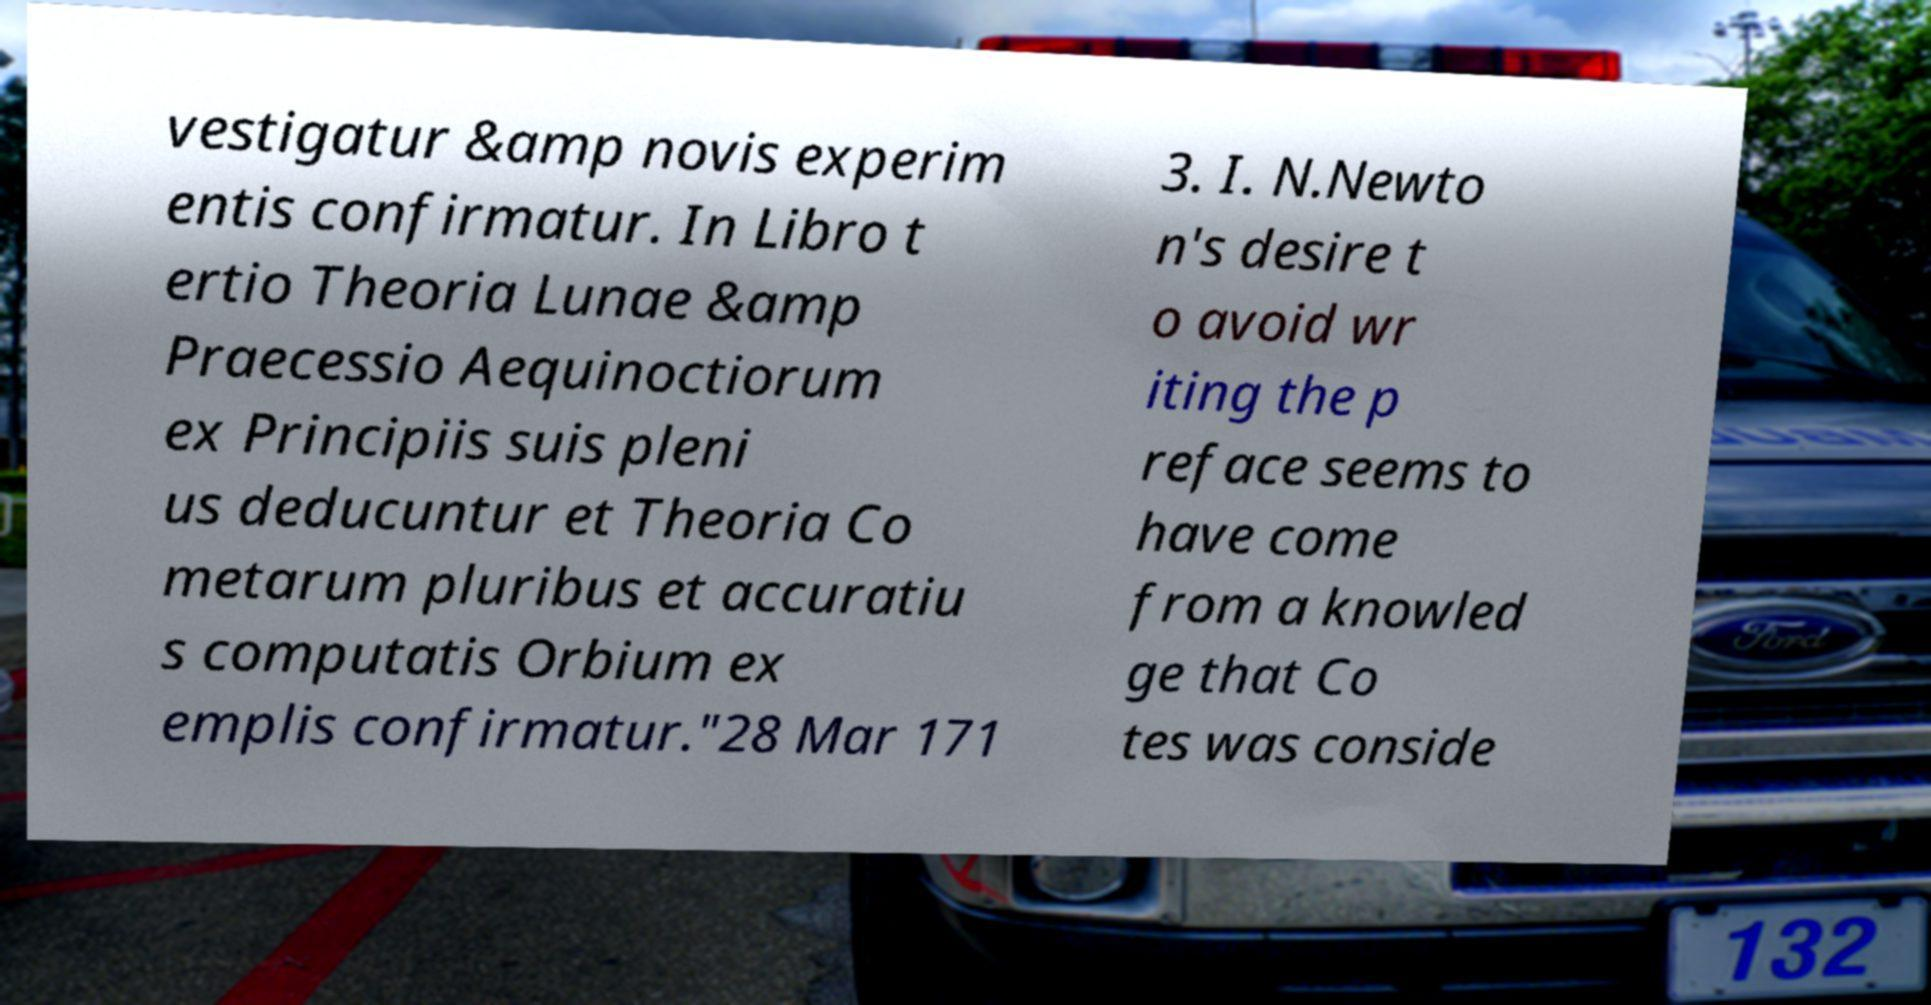Could you assist in decoding the text presented in this image and type it out clearly? vestigatur &amp novis experim entis confirmatur. In Libro t ertio Theoria Lunae &amp Praecessio Aequinoctiorum ex Principiis suis pleni us deducuntur et Theoria Co metarum pluribus et accuratiu s computatis Orbium ex emplis confirmatur."28 Mar 171 3. I. N.Newto n's desire t o avoid wr iting the p reface seems to have come from a knowled ge that Co tes was conside 